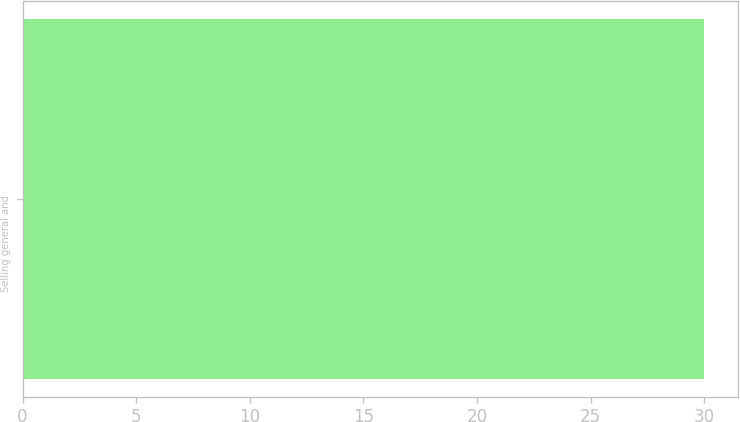Convert chart. <chart><loc_0><loc_0><loc_500><loc_500><bar_chart><fcel>Selling general and<nl><fcel>30<nl></chart> 